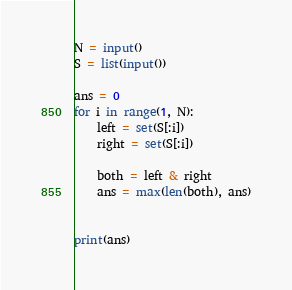<code> <loc_0><loc_0><loc_500><loc_500><_Python_>N = input()
S = list(input())

ans = 0
for i in range(1, N):
    left = set(S[:i])
    right = set(S[:i])

    both = left & right
    ans = max(len(both), ans)


print(ans)
</code> 